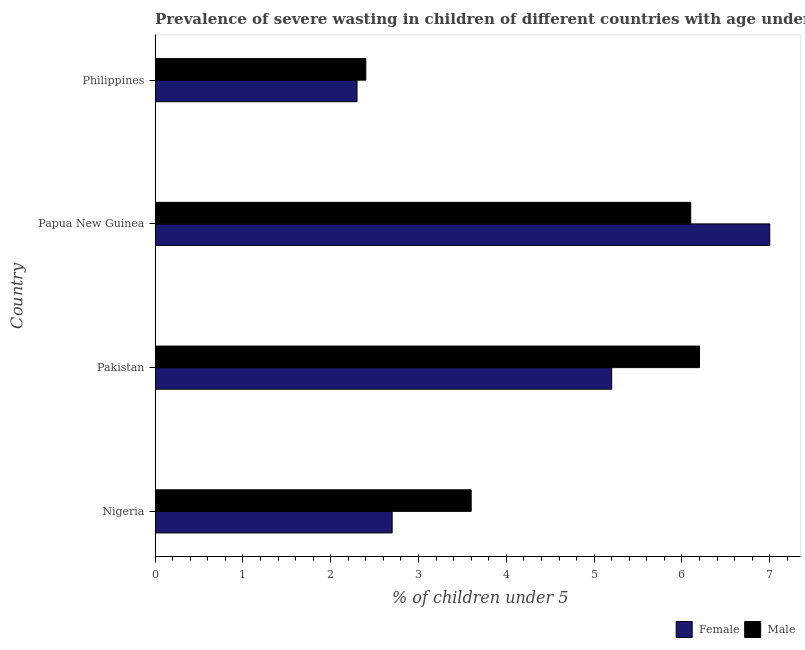How many groups of bars are there?
Offer a very short reply. 4. Are the number of bars per tick equal to the number of legend labels?
Make the answer very short. Yes. How many bars are there on the 2nd tick from the bottom?
Provide a succinct answer. 2. What is the label of the 1st group of bars from the top?
Provide a short and direct response. Philippines. What is the percentage of undernourished male children in Nigeria?
Provide a short and direct response. 3.6. Across all countries, what is the maximum percentage of undernourished female children?
Offer a terse response. 7. Across all countries, what is the minimum percentage of undernourished female children?
Offer a very short reply. 2.3. What is the total percentage of undernourished male children in the graph?
Offer a very short reply. 18.3. What is the difference between the percentage of undernourished female children in Philippines and the percentage of undernourished male children in Pakistan?
Your answer should be very brief. -3.9. What is the average percentage of undernourished female children per country?
Offer a terse response. 4.3. What is the ratio of the percentage of undernourished male children in Pakistan to that in Philippines?
Give a very brief answer. 2.58. Is the difference between the percentage of undernourished male children in Nigeria and Papua New Guinea greater than the difference between the percentage of undernourished female children in Nigeria and Papua New Guinea?
Your answer should be very brief. Yes. What is the difference between the highest and the lowest percentage of undernourished male children?
Provide a succinct answer. 3.8. Is the sum of the percentage of undernourished male children in Pakistan and Papua New Guinea greater than the maximum percentage of undernourished female children across all countries?
Make the answer very short. Yes. Are all the bars in the graph horizontal?
Offer a very short reply. Yes. How many countries are there in the graph?
Your response must be concise. 4. Are the values on the major ticks of X-axis written in scientific E-notation?
Your answer should be compact. No. How many legend labels are there?
Offer a very short reply. 2. How are the legend labels stacked?
Make the answer very short. Horizontal. What is the title of the graph?
Provide a short and direct response. Prevalence of severe wasting in children of different countries with age under 5 years. Does "Primary" appear as one of the legend labels in the graph?
Your response must be concise. No. What is the label or title of the X-axis?
Provide a short and direct response.  % of children under 5. What is the label or title of the Y-axis?
Make the answer very short. Country. What is the  % of children under 5 in Female in Nigeria?
Provide a succinct answer. 2.7. What is the  % of children under 5 of Male in Nigeria?
Make the answer very short. 3.6. What is the  % of children under 5 of Female in Pakistan?
Give a very brief answer. 5.2. What is the  % of children under 5 in Male in Pakistan?
Keep it short and to the point. 6.2. What is the  % of children under 5 in Male in Papua New Guinea?
Provide a short and direct response. 6.1. What is the  % of children under 5 in Female in Philippines?
Provide a short and direct response. 2.3. What is the  % of children under 5 of Male in Philippines?
Provide a succinct answer. 2.4. Across all countries, what is the maximum  % of children under 5 of Male?
Provide a succinct answer. 6.2. Across all countries, what is the minimum  % of children under 5 in Female?
Your response must be concise. 2.3. Across all countries, what is the minimum  % of children under 5 in Male?
Your answer should be very brief. 2.4. What is the difference between the  % of children under 5 of Female in Nigeria and that in Pakistan?
Your answer should be very brief. -2.5. What is the difference between the  % of children under 5 of Male in Nigeria and that in Pakistan?
Offer a very short reply. -2.6. What is the difference between the  % of children under 5 in Male in Nigeria and that in Papua New Guinea?
Provide a short and direct response. -2.5. What is the difference between the  % of children under 5 of Female in Pakistan and that in Papua New Guinea?
Your response must be concise. -1.8. What is the difference between the  % of children under 5 in Male in Pakistan and that in Philippines?
Give a very brief answer. 3.8. What is the difference between the  % of children under 5 of Female in Papua New Guinea and that in Philippines?
Your answer should be very brief. 4.7. What is the difference between the  % of children under 5 in Male in Papua New Guinea and that in Philippines?
Give a very brief answer. 3.7. What is the difference between the  % of children under 5 in Female in Nigeria and the  % of children under 5 in Male in Pakistan?
Provide a succinct answer. -3.5. What is the average  % of children under 5 of Female per country?
Provide a succinct answer. 4.3. What is the average  % of children under 5 in Male per country?
Offer a very short reply. 4.58. What is the difference between the  % of children under 5 of Female and  % of children under 5 of Male in Nigeria?
Your answer should be very brief. -0.9. What is the difference between the  % of children under 5 in Female and  % of children under 5 in Male in Papua New Guinea?
Give a very brief answer. 0.9. What is the ratio of the  % of children under 5 of Female in Nigeria to that in Pakistan?
Provide a short and direct response. 0.52. What is the ratio of the  % of children under 5 in Male in Nigeria to that in Pakistan?
Keep it short and to the point. 0.58. What is the ratio of the  % of children under 5 of Female in Nigeria to that in Papua New Guinea?
Your answer should be very brief. 0.39. What is the ratio of the  % of children under 5 of Male in Nigeria to that in Papua New Guinea?
Keep it short and to the point. 0.59. What is the ratio of the  % of children under 5 of Female in Nigeria to that in Philippines?
Provide a succinct answer. 1.17. What is the ratio of the  % of children under 5 of Male in Nigeria to that in Philippines?
Give a very brief answer. 1.5. What is the ratio of the  % of children under 5 in Female in Pakistan to that in Papua New Guinea?
Offer a very short reply. 0.74. What is the ratio of the  % of children under 5 in Male in Pakistan to that in Papua New Guinea?
Give a very brief answer. 1.02. What is the ratio of the  % of children under 5 in Female in Pakistan to that in Philippines?
Give a very brief answer. 2.26. What is the ratio of the  % of children under 5 in Male in Pakistan to that in Philippines?
Keep it short and to the point. 2.58. What is the ratio of the  % of children under 5 in Female in Papua New Guinea to that in Philippines?
Provide a short and direct response. 3.04. What is the ratio of the  % of children under 5 in Male in Papua New Guinea to that in Philippines?
Make the answer very short. 2.54. What is the difference between the highest and the second highest  % of children under 5 of Female?
Provide a short and direct response. 1.8. What is the difference between the highest and the lowest  % of children under 5 of Female?
Your response must be concise. 4.7. What is the difference between the highest and the lowest  % of children under 5 of Male?
Your answer should be compact. 3.8. 